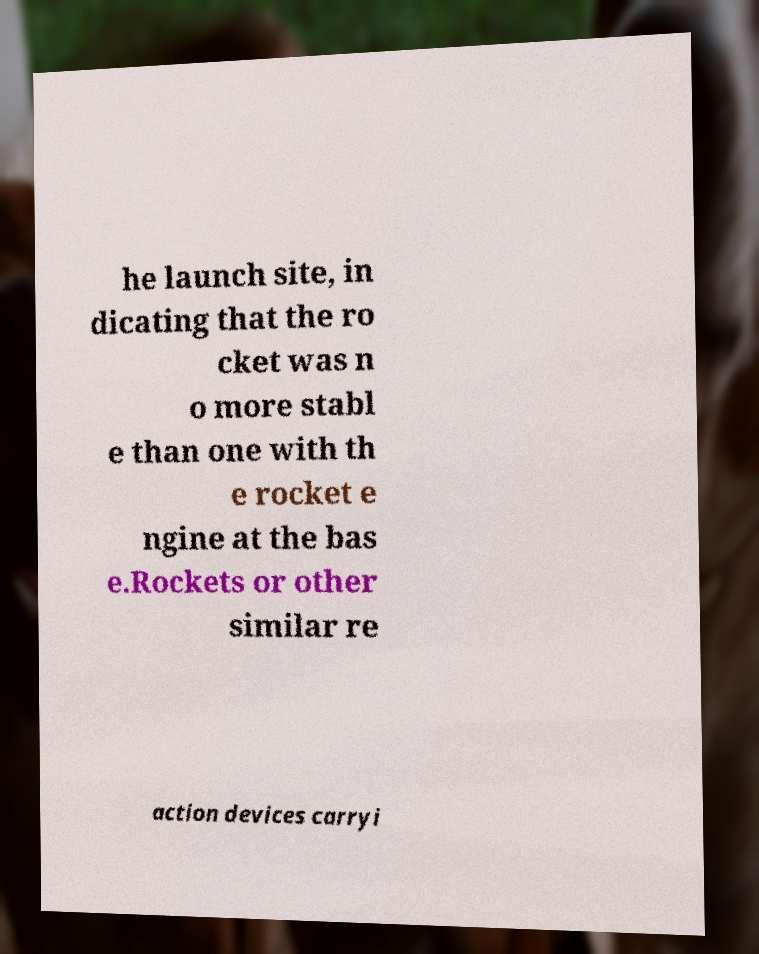Please identify and transcribe the text found in this image. he launch site, in dicating that the ro cket was n o more stabl e than one with th e rocket e ngine at the bas e.Rockets or other similar re action devices carryi 